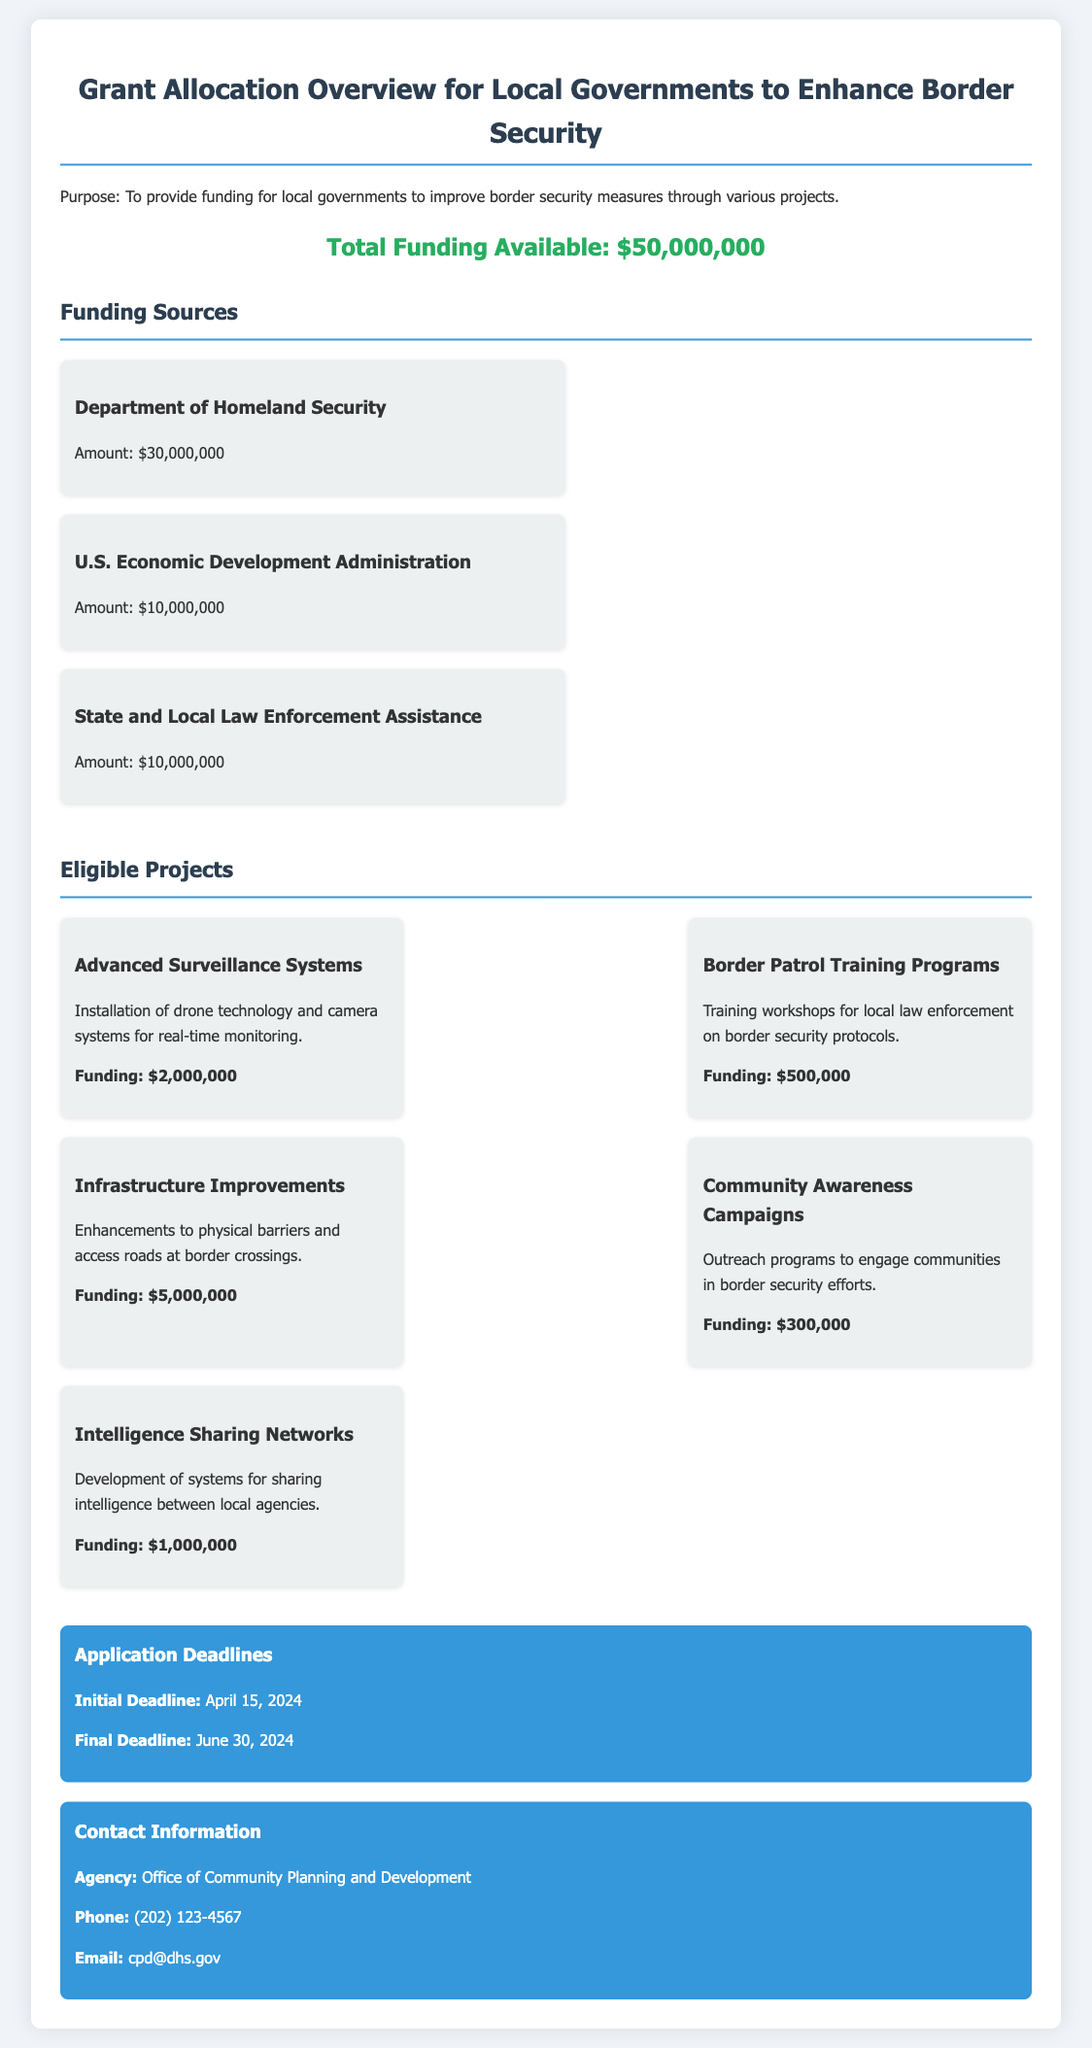What is the total funding available? The total funding available is stated clearly at the top of the document as $50,000,000.
Answer: $50,000,000 Who is providing the largest funding source? The largest funding source is mentioned just below the total funding available, which is the Department of Homeland Security.
Answer: Department of Homeland Security What is the funding amount for Advanced Surveillance Systems? The funding amount for Advanced Surveillance Systems is specified within the eligible projects section of the document as $2,000,000.
Answer: $2,000,000 When is the initial application deadline? The initial application deadline is outlined in the deadlines section of the document as April 15, 2024.
Answer: April 15, 2024 How much funding is allocated for Community Awareness Campaigns? The funding allocated for Community Awareness Campaigns is listed in the eligible projects section as $300,000.
Answer: $300,000 What is the purpose of the grant allocation? The purpose of the grant allocation is briefly stated in the introductory paragraph of the document as improving border security measures.
Answer: Improving border security measures What type of projects are eligible for funding? The document provides a list of eligible projects which includes systems for surveillance, training programs, and more.
Answer: Surveillance systems, training programs, infrastructure improvements, community campaigns, intelligence networks What is the phone number for the contact agency? The phone number for the contact agency is mentioned in the contact information section and is stated as (202) 123-4567.
Answer: (202) 123-4567 